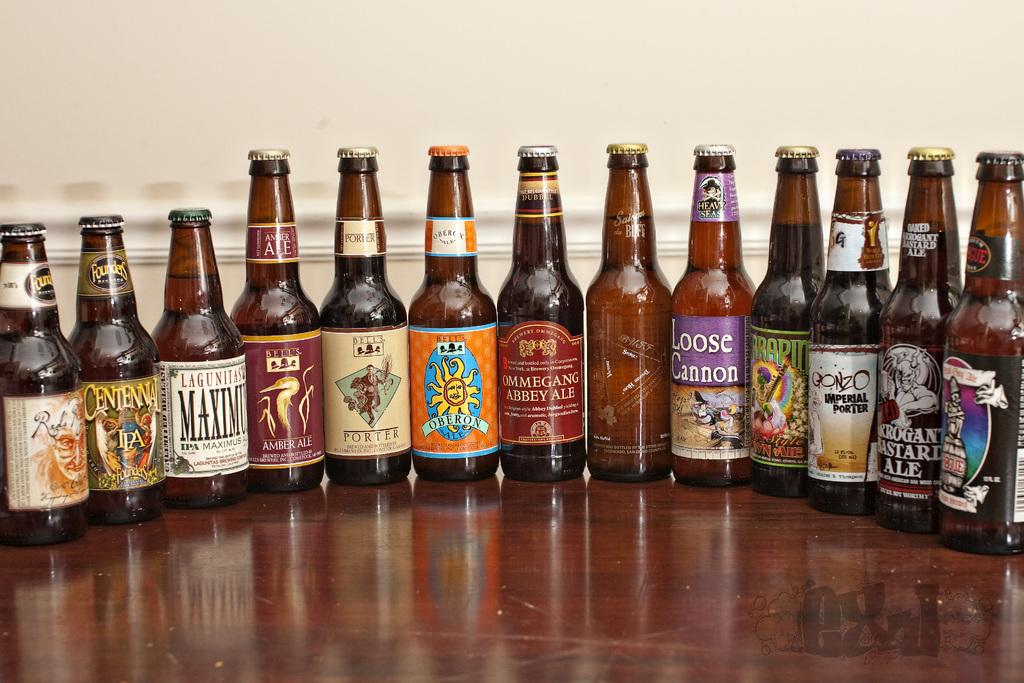Provide a one-sentence caption for the provided image. A row of beer bottles including Loose Cannon and Arrogant Bastard Ale. 